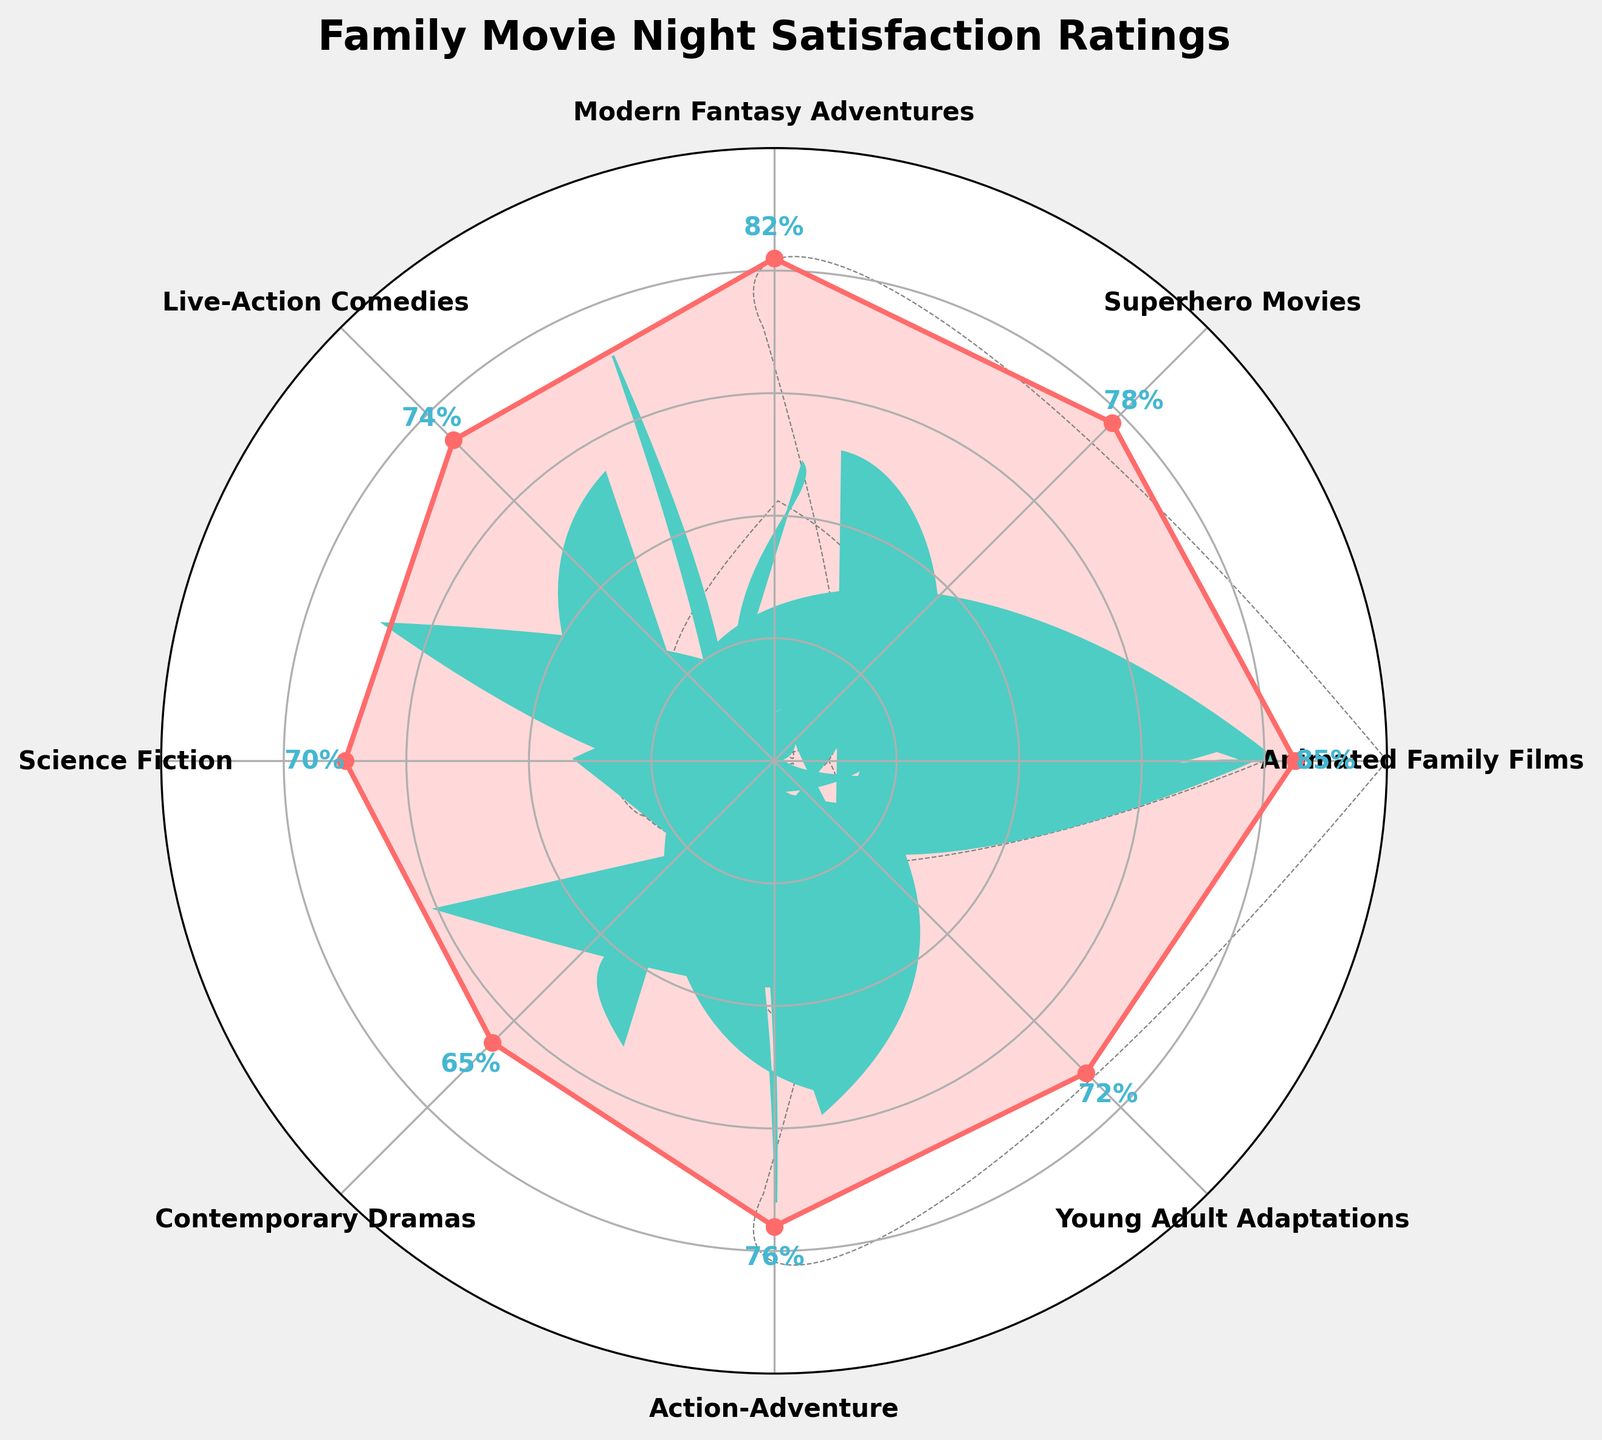what is the satisfaction rating for Animated Family Films? The satisfaction rating for Animated Family Films is shown directly on the plot next to the corresponding genre.
Answer: 85% which genre has the lowest satisfaction rating? By looking at the plotted values, Contemporary Dramas have the lowest satisfaction rating.
Answer: Contemporary Dramas how many genres have a satisfaction rating of 70 or above? Count the number of genres with satisfaction ratings highlighted in the plot that are 70 or more.
Answer: 7 what is the difference in satisfaction ratings between Science Fiction and Modern Fantasy Adventures? Subtract the satisfaction rating of Science Fiction from Modern Fantasy Adventures.
Answer: 12 which genres have satisfaction ratings greater than Superhero Movies? Look at all genres in the plot and compare their satisfaction ratings to that of Superhero Movies (78%).
Answer: Animated Family Films, Modern Fantasy Adventures what's the average satisfaction rating among all genres? Sum all the satisfaction ratings and divide by the number of genres. (85 + 78 + 82 + 74 + 70 + 65 + 76 + 72) / 8 = 604/8 = 75.5
Answer: 75.5 what is the title of the chart? The title is displayed prominently at the top of the chart.
Answer: Family Movie Night Satisfaction Ratings which genre has the closest satisfaction rating to 75? Compare each genre's satisfaction rating to see which is closest to 75. Action-Adventure has a rating of 76, which is closest.
Answer: Action-Adventure how many circular gridlines are present in the plot? Count the number of circular gridlines in the background of the gauge plot for visual reference.
Answer: 4 